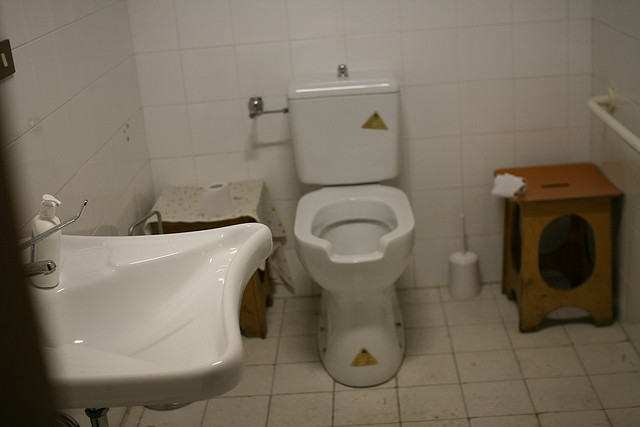What items can be seen on the floor? On the floor, there is a mat in front of the toilet, likely for comfort and to prevent slipping on wet tiles. Additionally, there's a trash bin next to the toilet. 